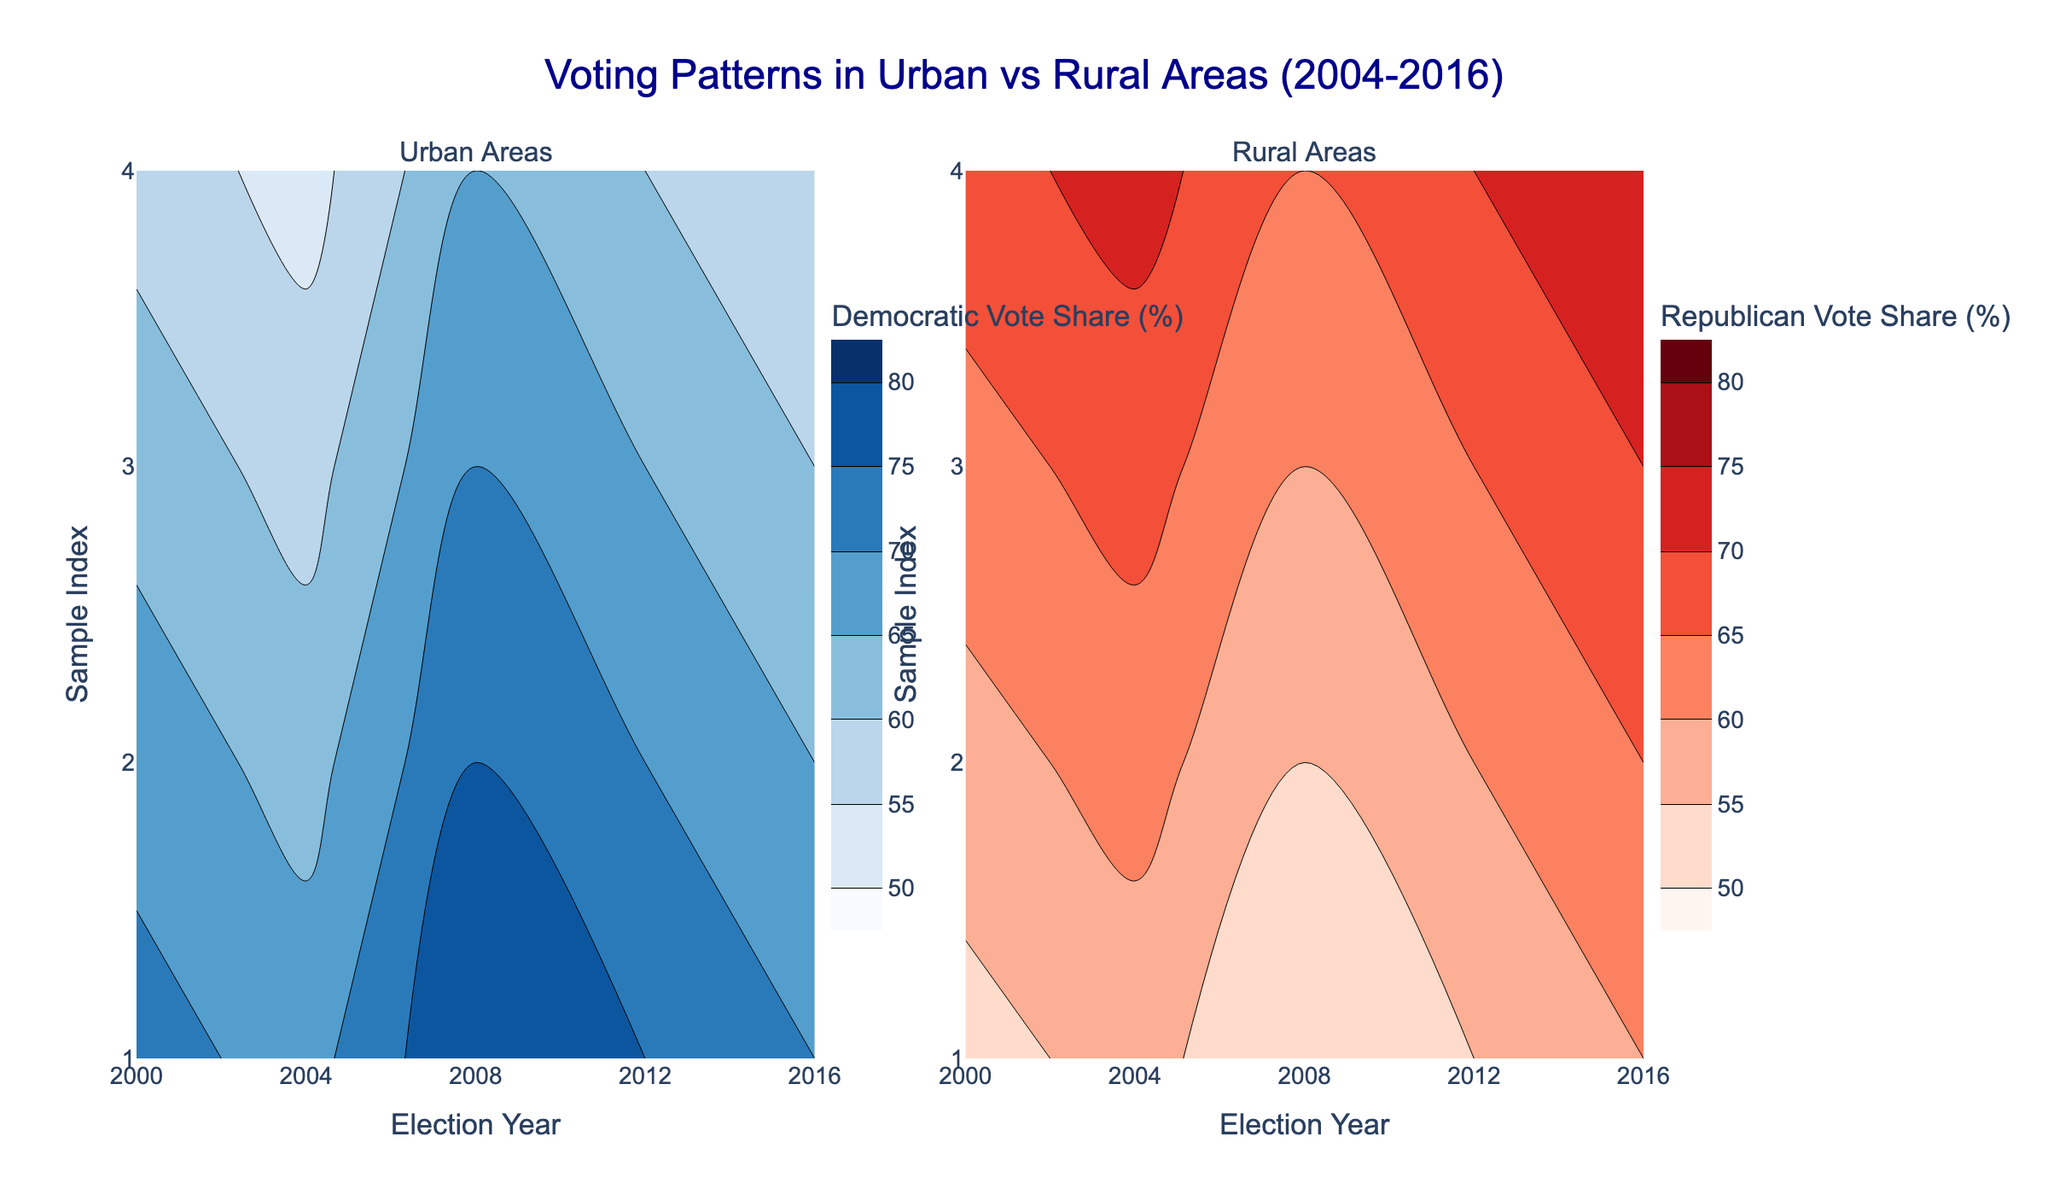What is the title of the plot? The title of the plot is usually displayed at the top of the figure, and in this case, it should be identifiable by its large font size and positioning.
Answer: Voting Patterns in Urban vs Rural Areas (2004-2016) Which area type is represented in the left subplot? The left subplot is titled "Urban Areas" which indicates that it shows the data corresponding to urban regions.
Answer: Urban Areas What do the colors represent in the left subplot? The colors in the left subplot range from a lighter blue to a darker blue. The color bar on the side indicates these colors represent the percentage of Democratic vote share.
Answer: Democratic vote share percentage How do the Democratic vote shares in Urban areas compare from 2004 to 2016? By comparing the contour colors in the left subplot from the year 2004 to 2016, there is a visible deepening of the blue color, indicating an increase in Democratic vote share over the years.
Answer: They increased What's the contour interval for the democratic vote share in Urban areas? The contour interval can be determined by checking the contours settings in the figure, which specify how the data has been visually divided.
Answer: 5% Between which years is the Rural Republican vote share highest, and in which subplot can this be seen? By observing the right subplot titled "Rural Areas", the years with the deepest red color indicate higher Republican vote shares. The intensest red is visualized typically around 2004 and 2008.
Answer: 2004 and 2008, right subplot What is the general trend of Republican vote share in Rural areas from 2004 to 2016? Observing the change in the depth of the red color in the right subplot over the years can tell us the trend. The red color intensity seems to diminish, indicating a decrease in Republican vote share.
Answer: It decreased In which year do urban areas have the most intense Democratic vote share? By looking at the color gradient in the left subplot, the most intense blue represents the highest Democratic vote share, which occurs in the year closer to 2016.
Answer: 2016 Is there a visible contrast between urban and rural voting patterns from this plot? Comparing the blue colors in the left subplot (urban) and red colors in the right subplot (rural), there is a visible contrast suggesting urban areas lean Democratic and rural areas lean Republican.
Answer: Yes Which area and year combination has the lowest Democratic vote share? The contour in the left subplot that is lightest blue represents the lowest Democratic vote share, corresponding to earlier years around 2004.
Answer: Urban, 2004 